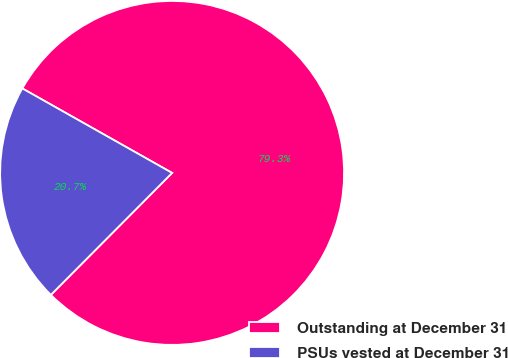Convert chart to OTSL. <chart><loc_0><loc_0><loc_500><loc_500><pie_chart><fcel>Outstanding at December 31<fcel>PSUs vested at December 31<nl><fcel>79.28%<fcel>20.72%<nl></chart> 